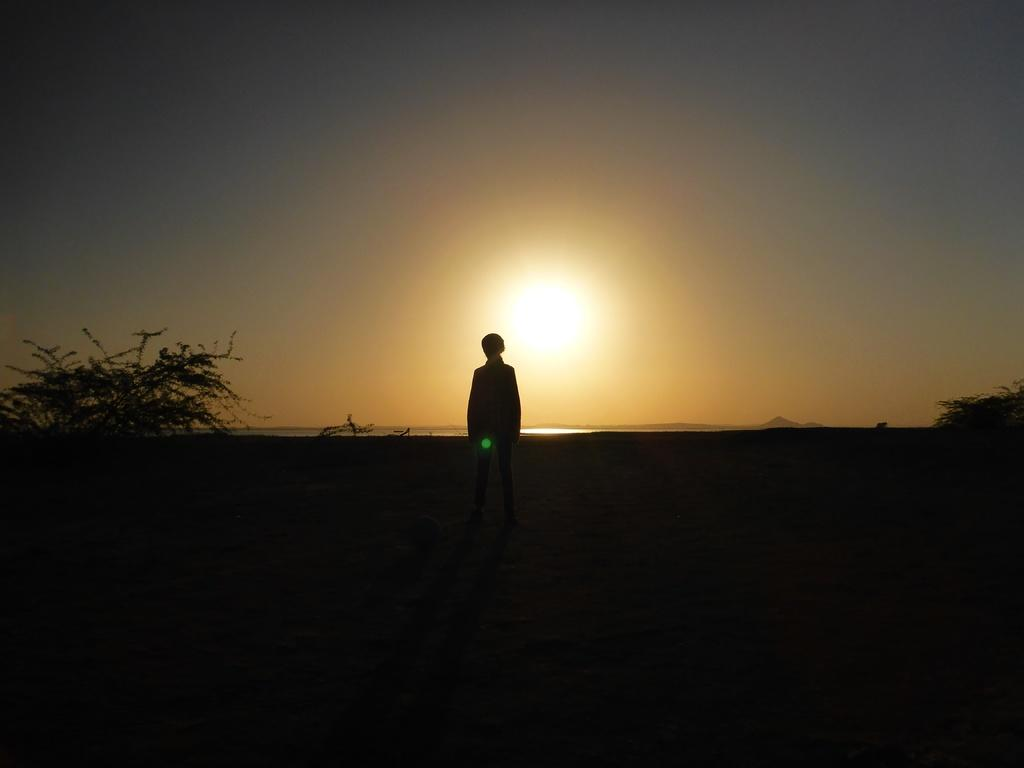What is the main subject of the image? There is a person standing in the image. What can be seen on the sides of the image? There are trees on both the right and left sides of the image. What is visible in the background of the image? The sky is visible in the background of the image. How would you describe the lighting at the bottom of the image? The bottom of the image is dark. Can you see a board being used by the snake in the image? There is no snake or board present in the image. 